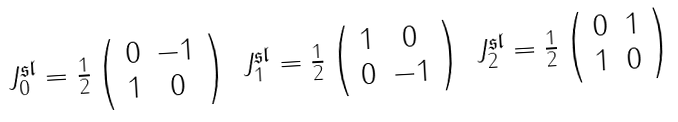<formula> <loc_0><loc_0><loc_500><loc_500>\begin{array} { c c c } J _ { 0 } ^ { \mathfrak { s l } } = \frac { 1 } { 2 } \left ( \begin{array} { c c } 0 & - 1 \\ 1 & 0 \end{array} \right ) & J _ { 1 } ^ { \mathfrak { s l } } = \frac { 1 } { 2 } \left ( \begin{array} { c c } 1 & 0 \\ 0 & - 1 \end{array} \right ) & J _ { 2 } ^ { \mathfrak { s l } } = \frac { 1 } { 2 } \left ( \begin{array} { c c } 0 & 1 \\ 1 & 0 \end{array} \right ) \end{array}</formula> 